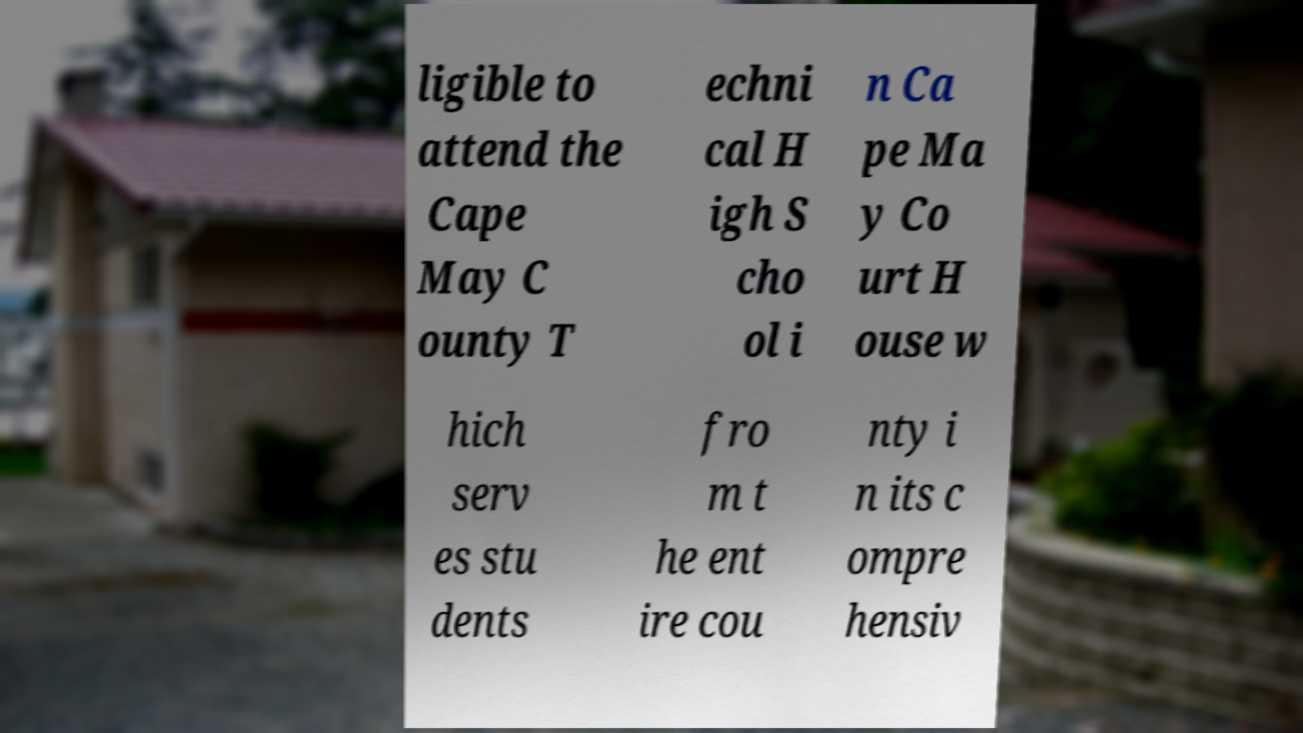What messages or text are displayed in this image? I need them in a readable, typed format. ligible to attend the Cape May C ounty T echni cal H igh S cho ol i n Ca pe Ma y Co urt H ouse w hich serv es stu dents fro m t he ent ire cou nty i n its c ompre hensiv 